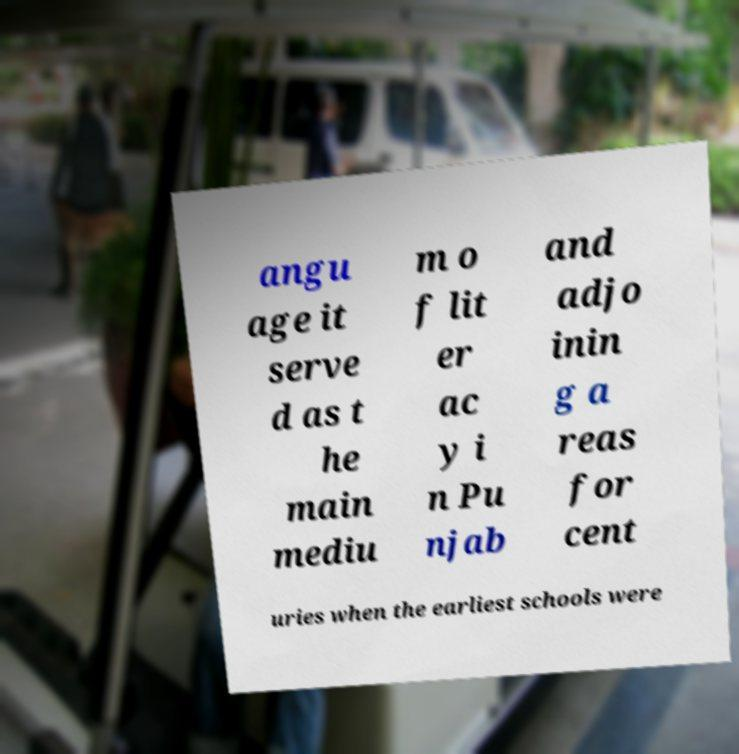Can you read and provide the text displayed in the image?This photo seems to have some interesting text. Can you extract and type it out for me? angu age it serve d as t he main mediu m o f lit er ac y i n Pu njab and adjo inin g a reas for cent uries when the earliest schools were 